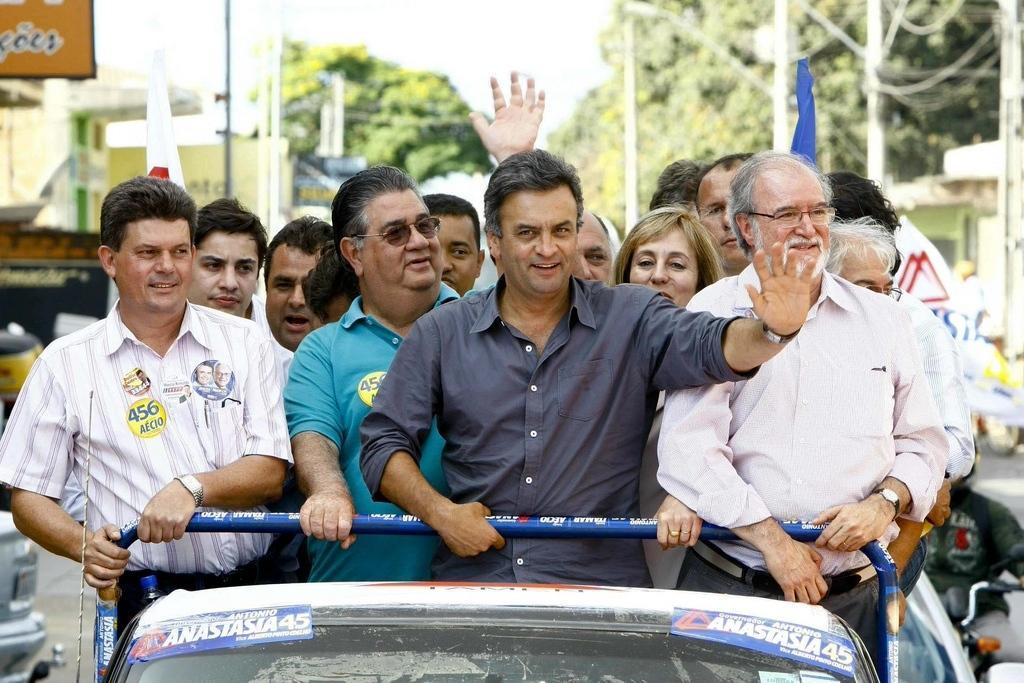How would you summarize this image in a sentence or two? There are many people standing on a vehicle. On the vehicle there are posters. In the back there are trees and many other things. 